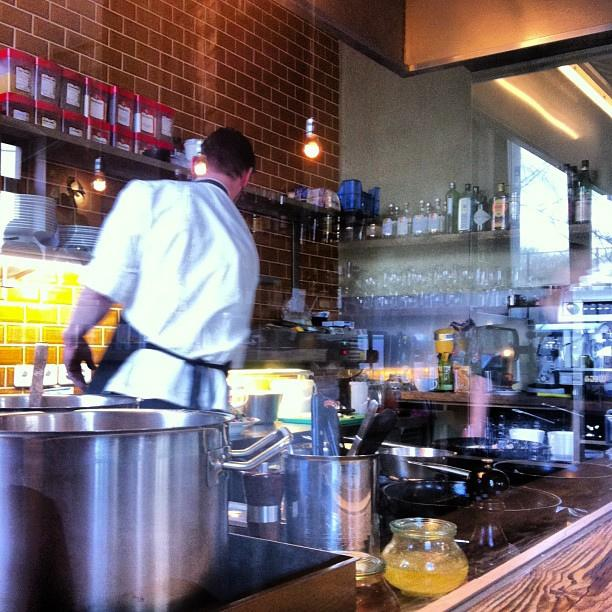What is on the counter?

Choices:
A) cat
B) pizza pie
C) dog
D) pot pot 